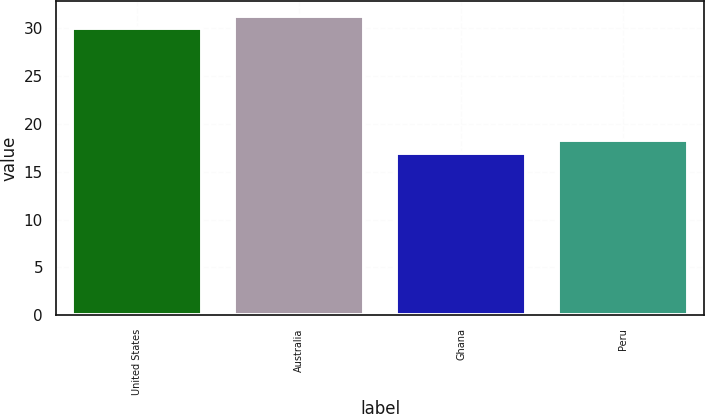<chart> <loc_0><loc_0><loc_500><loc_500><bar_chart><fcel>United States<fcel>Australia<fcel>Ghana<fcel>Peru<nl><fcel>30<fcel>31.3<fcel>17<fcel>18.3<nl></chart> 